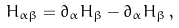<formula> <loc_0><loc_0><loc_500><loc_500>H _ { \alpha \beta } = \partial _ { \alpha } H _ { \beta } - \partial _ { \alpha } H _ { \beta } \, ,</formula> 